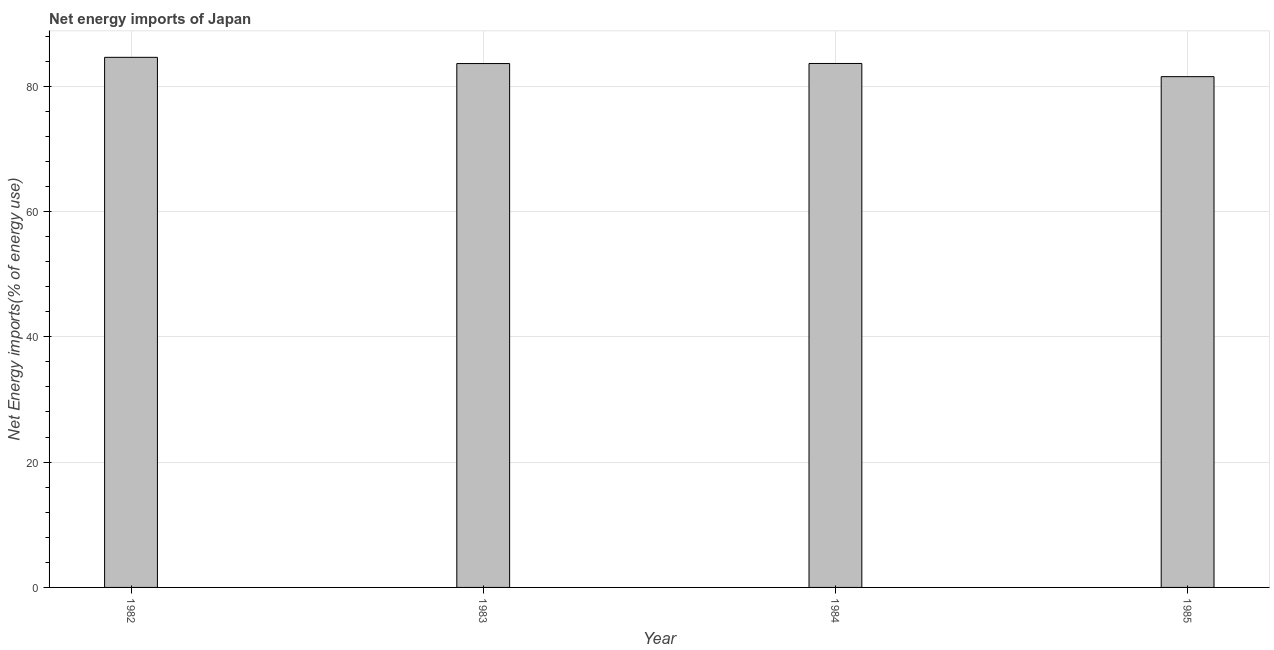Does the graph contain any zero values?
Keep it short and to the point. No. What is the title of the graph?
Keep it short and to the point. Net energy imports of Japan. What is the label or title of the Y-axis?
Keep it short and to the point. Net Energy imports(% of energy use). What is the energy imports in 1984?
Your answer should be very brief. 83.63. Across all years, what is the maximum energy imports?
Offer a terse response. 84.61. Across all years, what is the minimum energy imports?
Offer a terse response. 81.52. What is the sum of the energy imports?
Offer a very short reply. 333.38. What is the difference between the energy imports in 1984 and 1985?
Provide a succinct answer. 2.1. What is the average energy imports per year?
Provide a short and direct response. 83.34. What is the median energy imports?
Your response must be concise. 83.62. What is the difference between the highest and the lowest energy imports?
Keep it short and to the point. 3.08. How many bars are there?
Ensure brevity in your answer.  4. Are all the bars in the graph horizontal?
Your response must be concise. No. How many years are there in the graph?
Your answer should be very brief. 4. What is the difference between two consecutive major ticks on the Y-axis?
Keep it short and to the point. 20. What is the Net Energy imports(% of energy use) in 1982?
Provide a succinct answer. 84.61. What is the Net Energy imports(% of energy use) of 1983?
Your response must be concise. 83.62. What is the Net Energy imports(% of energy use) in 1984?
Offer a very short reply. 83.63. What is the Net Energy imports(% of energy use) of 1985?
Keep it short and to the point. 81.52. What is the difference between the Net Energy imports(% of energy use) in 1982 and 1983?
Ensure brevity in your answer.  0.99. What is the difference between the Net Energy imports(% of energy use) in 1982 and 1984?
Give a very brief answer. 0.98. What is the difference between the Net Energy imports(% of energy use) in 1982 and 1985?
Provide a short and direct response. 3.08. What is the difference between the Net Energy imports(% of energy use) in 1983 and 1984?
Your response must be concise. -0.01. What is the difference between the Net Energy imports(% of energy use) in 1983 and 1985?
Give a very brief answer. 2.09. What is the difference between the Net Energy imports(% of energy use) in 1984 and 1985?
Your response must be concise. 2.1. What is the ratio of the Net Energy imports(% of energy use) in 1982 to that in 1985?
Provide a short and direct response. 1.04. What is the ratio of the Net Energy imports(% of energy use) in 1983 to that in 1984?
Your answer should be very brief. 1. What is the ratio of the Net Energy imports(% of energy use) in 1984 to that in 1985?
Ensure brevity in your answer.  1.03. 